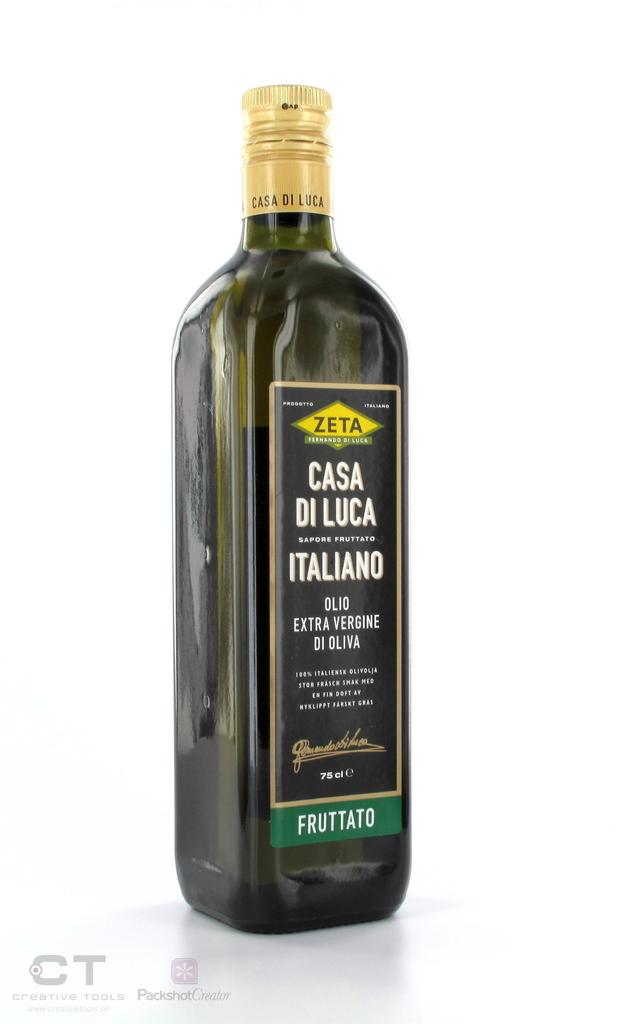What object is present in the image? There is a bottle in the image. What color is the background of the image? The background of the image is white. What feature can be found on the bottle? There is a label on the bottle. What information is provided on the label? The label contains text. What type of flooring is visible in the image? There is no flooring visible in the image; it only shows a bottle with a white background. Can you describe the edge of the bottle in the image? The edge of the bottle is not visible in the image, as it only shows the label and the white background. 